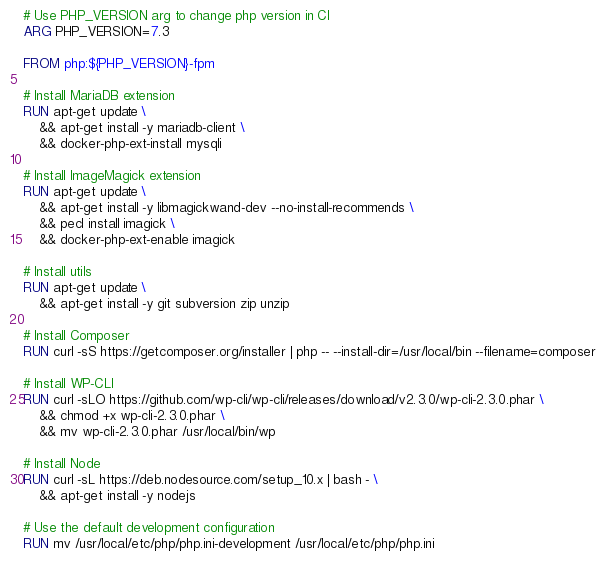<code> <loc_0><loc_0><loc_500><loc_500><_Dockerfile_># Use PHP_VERSION arg to change php version in CI
ARG PHP_VERSION=7.3

FROM php:${PHP_VERSION}-fpm

# Install MariaDB extension
RUN apt-get update \
	&& apt-get install -y mariadb-client \
    && docker-php-ext-install mysqli

# Install ImageMagick extension
RUN apt-get update \
	&& apt-get install -y libmagickwand-dev --no-install-recommends \
    && pecl install imagick \
    && docker-php-ext-enable imagick

# Install utils
RUN apt-get update \
	&& apt-get install -y git subversion zip unzip

# Install Composer
RUN curl -sS https://getcomposer.org/installer | php -- --install-dir=/usr/local/bin --filename=composer

# Install WP-CLI
RUN curl -sLO https://github.com/wp-cli/wp-cli/releases/download/v2.3.0/wp-cli-2.3.0.phar \
    && chmod +x wp-cli-2.3.0.phar \
	&& mv wp-cli-2.3.0.phar /usr/local/bin/wp

# Install Node
RUN curl -sL https://deb.nodesource.com/setup_10.x | bash - \
	&& apt-get install -y nodejs

# Use the default development configuration
RUN mv /usr/local/etc/php/php.ini-development /usr/local/etc/php/php.ini
</code> 